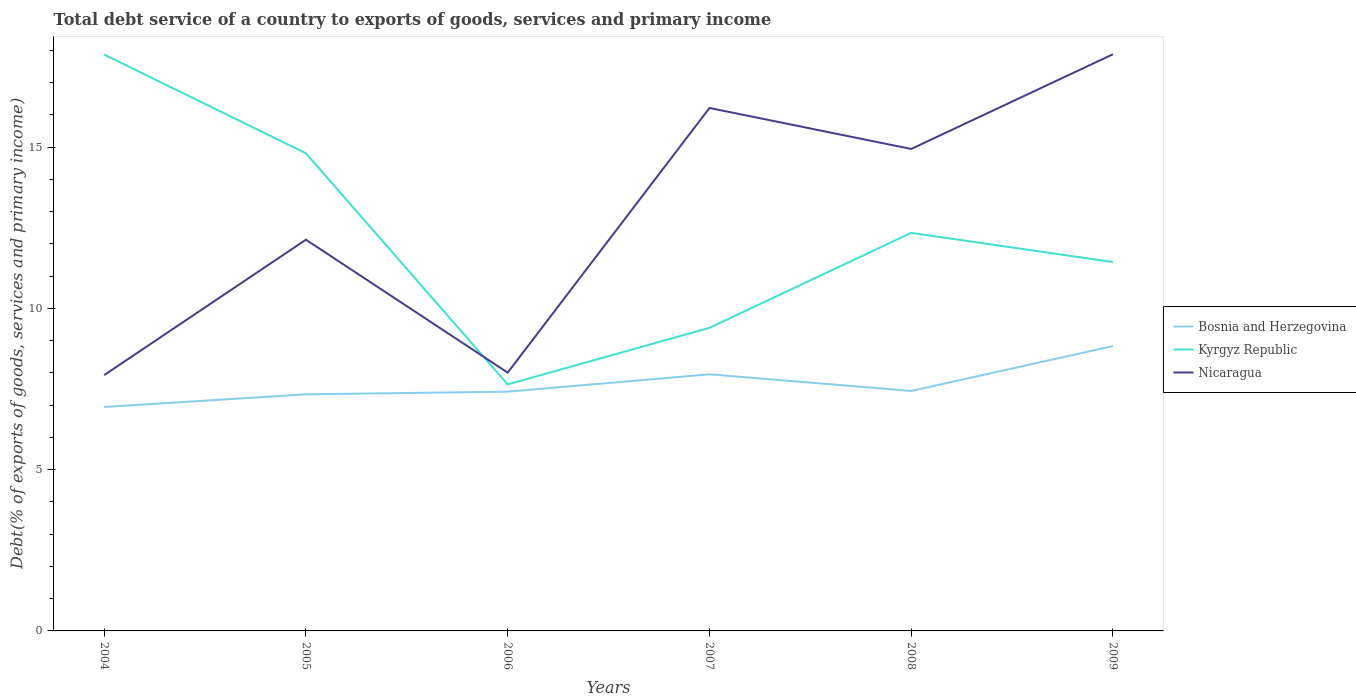Across all years, what is the maximum total debt service in Kyrgyz Republic?
Provide a succinct answer. 7.64. What is the total total debt service in Nicaragua in the graph?
Offer a terse response. -8.21. What is the difference between the highest and the second highest total debt service in Bosnia and Herzegovina?
Give a very brief answer. 1.89. What is the difference between the highest and the lowest total debt service in Kyrgyz Republic?
Ensure brevity in your answer.  3. Is the total debt service in Kyrgyz Republic strictly greater than the total debt service in Nicaragua over the years?
Provide a short and direct response. No. Does the graph contain grids?
Your response must be concise. No. Where does the legend appear in the graph?
Provide a short and direct response. Center right. How many legend labels are there?
Provide a succinct answer. 3. How are the legend labels stacked?
Offer a terse response. Vertical. What is the title of the graph?
Offer a terse response. Total debt service of a country to exports of goods, services and primary income. Does "Senegal" appear as one of the legend labels in the graph?
Give a very brief answer. No. What is the label or title of the X-axis?
Give a very brief answer. Years. What is the label or title of the Y-axis?
Your answer should be compact. Debt(% of exports of goods, services and primary income). What is the Debt(% of exports of goods, services and primary income) of Bosnia and Herzegovina in 2004?
Give a very brief answer. 6.94. What is the Debt(% of exports of goods, services and primary income) of Kyrgyz Republic in 2004?
Give a very brief answer. 17.87. What is the Debt(% of exports of goods, services and primary income) in Nicaragua in 2004?
Keep it short and to the point. 7.93. What is the Debt(% of exports of goods, services and primary income) in Bosnia and Herzegovina in 2005?
Keep it short and to the point. 7.34. What is the Debt(% of exports of goods, services and primary income) of Kyrgyz Republic in 2005?
Ensure brevity in your answer.  14.81. What is the Debt(% of exports of goods, services and primary income) of Nicaragua in 2005?
Your answer should be very brief. 12.13. What is the Debt(% of exports of goods, services and primary income) in Bosnia and Herzegovina in 2006?
Ensure brevity in your answer.  7.42. What is the Debt(% of exports of goods, services and primary income) in Kyrgyz Republic in 2006?
Provide a short and direct response. 7.64. What is the Debt(% of exports of goods, services and primary income) of Nicaragua in 2006?
Provide a succinct answer. 8.01. What is the Debt(% of exports of goods, services and primary income) of Bosnia and Herzegovina in 2007?
Your response must be concise. 7.96. What is the Debt(% of exports of goods, services and primary income) of Kyrgyz Republic in 2007?
Give a very brief answer. 9.4. What is the Debt(% of exports of goods, services and primary income) in Nicaragua in 2007?
Your answer should be very brief. 16.22. What is the Debt(% of exports of goods, services and primary income) in Bosnia and Herzegovina in 2008?
Make the answer very short. 7.44. What is the Debt(% of exports of goods, services and primary income) in Kyrgyz Republic in 2008?
Provide a succinct answer. 12.34. What is the Debt(% of exports of goods, services and primary income) of Nicaragua in 2008?
Provide a short and direct response. 14.94. What is the Debt(% of exports of goods, services and primary income) in Bosnia and Herzegovina in 2009?
Provide a succinct answer. 8.83. What is the Debt(% of exports of goods, services and primary income) in Kyrgyz Republic in 2009?
Your answer should be compact. 11.44. What is the Debt(% of exports of goods, services and primary income) in Nicaragua in 2009?
Provide a succinct answer. 17.88. Across all years, what is the maximum Debt(% of exports of goods, services and primary income) of Bosnia and Herzegovina?
Provide a short and direct response. 8.83. Across all years, what is the maximum Debt(% of exports of goods, services and primary income) in Kyrgyz Republic?
Make the answer very short. 17.87. Across all years, what is the maximum Debt(% of exports of goods, services and primary income) in Nicaragua?
Keep it short and to the point. 17.88. Across all years, what is the minimum Debt(% of exports of goods, services and primary income) in Bosnia and Herzegovina?
Your response must be concise. 6.94. Across all years, what is the minimum Debt(% of exports of goods, services and primary income) in Kyrgyz Republic?
Your response must be concise. 7.64. Across all years, what is the minimum Debt(% of exports of goods, services and primary income) of Nicaragua?
Offer a very short reply. 7.93. What is the total Debt(% of exports of goods, services and primary income) in Bosnia and Herzegovina in the graph?
Provide a succinct answer. 45.93. What is the total Debt(% of exports of goods, services and primary income) in Kyrgyz Republic in the graph?
Offer a very short reply. 73.5. What is the total Debt(% of exports of goods, services and primary income) of Nicaragua in the graph?
Your answer should be very brief. 77.11. What is the difference between the Debt(% of exports of goods, services and primary income) in Bosnia and Herzegovina in 2004 and that in 2005?
Offer a terse response. -0.39. What is the difference between the Debt(% of exports of goods, services and primary income) in Kyrgyz Republic in 2004 and that in 2005?
Provide a succinct answer. 3.06. What is the difference between the Debt(% of exports of goods, services and primary income) of Nicaragua in 2004 and that in 2005?
Offer a terse response. -4.2. What is the difference between the Debt(% of exports of goods, services and primary income) of Bosnia and Herzegovina in 2004 and that in 2006?
Provide a short and direct response. -0.47. What is the difference between the Debt(% of exports of goods, services and primary income) of Kyrgyz Republic in 2004 and that in 2006?
Give a very brief answer. 10.23. What is the difference between the Debt(% of exports of goods, services and primary income) of Nicaragua in 2004 and that in 2006?
Offer a very short reply. -0.08. What is the difference between the Debt(% of exports of goods, services and primary income) in Bosnia and Herzegovina in 2004 and that in 2007?
Your answer should be compact. -1.01. What is the difference between the Debt(% of exports of goods, services and primary income) in Kyrgyz Republic in 2004 and that in 2007?
Your response must be concise. 8.47. What is the difference between the Debt(% of exports of goods, services and primary income) of Nicaragua in 2004 and that in 2007?
Your answer should be compact. -8.28. What is the difference between the Debt(% of exports of goods, services and primary income) in Bosnia and Herzegovina in 2004 and that in 2008?
Your response must be concise. -0.5. What is the difference between the Debt(% of exports of goods, services and primary income) of Kyrgyz Republic in 2004 and that in 2008?
Your response must be concise. 5.53. What is the difference between the Debt(% of exports of goods, services and primary income) in Nicaragua in 2004 and that in 2008?
Ensure brevity in your answer.  -7.01. What is the difference between the Debt(% of exports of goods, services and primary income) of Bosnia and Herzegovina in 2004 and that in 2009?
Your response must be concise. -1.89. What is the difference between the Debt(% of exports of goods, services and primary income) in Kyrgyz Republic in 2004 and that in 2009?
Offer a very short reply. 6.43. What is the difference between the Debt(% of exports of goods, services and primary income) in Nicaragua in 2004 and that in 2009?
Provide a short and direct response. -9.95. What is the difference between the Debt(% of exports of goods, services and primary income) in Bosnia and Herzegovina in 2005 and that in 2006?
Keep it short and to the point. -0.08. What is the difference between the Debt(% of exports of goods, services and primary income) in Kyrgyz Republic in 2005 and that in 2006?
Ensure brevity in your answer.  7.17. What is the difference between the Debt(% of exports of goods, services and primary income) in Nicaragua in 2005 and that in 2006?
Keep it short and to the point. 4.12. What is the difference between the Debt(% of exports of goods, services and primary income) of Bosnia and Herzegovina in 2005 and that in 2007?
Your response must be concise. -0.62. What is the difference between the Debt(% of exports of goods, services and primary income) of Kyrgyz Republic in 2005 and that in 2007?
Your response must be concise. 5.41. What is the difference between the Debt(% of exports of goods, services and primary income) in Nicaragua in 2005 and that in 2007?
Make the answer very short. -4.08. What is the difference between the Debt(% of exports of goods, services and primary income) of Bosnia and Herzegovina in 2005 and that in 2008?
Your answer should be very brief. -0.11. What is the difference between the Debt(% of exports of goods, services and primary income) in Kyrgyz Republic in 2005 and that in 2008?
Ensure brevity in your answer.  2.47. What is the difference between the Debt(% of exports of goods, services and primary income) in Nicaragua in 2005 and that in 2008?
Your answer should be very brief. -2.81. What is the difference between the Debt(% of exports of goods, services and primary income) of Bosnia and Herzegovina in 2005 and that in 2009?
Give a very brief answer. -1.5. What is the difference between the Debt(% of exports of goods, services and primary income) of Kyrgyz Republic in 2005 and that in 2009?
Offer a very short reply. 3.37. What is the difference between the Debt(% of exports of goods, services and primary income) in Nicaragua in 2005 and that in 2009?
Offer a terse response. -5.75. What is the difference between the Debt(% of exports of goods, services and primary income) of Bosnia and Herzegovina in 2006 and that in 2007?
Your answer should be compact. -0.54. What is the difference between the Debt(% of exports of goods, services and primary income) of Kyrgyz Republic in 2006 and that in 2007?
Give a very brief answer. -1.75. What is the difference between the Debt(% of exports of goods, services and primary income) of Nicaragua in 2006 and that in 2007?
Offer a very short reply. -8.21. What is the difference between the Debt(% of exports of goods, services and primary income) of Bosnia and Herzegovina in 2006 and that in 2008?
Give a very brief answer. -0.02. What is the difference between the Debt(% of exports of goods, services and primary income) of Kyrgyz Republic in 2006 and that in 2008?
Offer a very short reply. -4.7. What is the difference between the Debt(% of exports of goods, services and primary income) in Nicaragua in 2006 and that in 2008?
Your response must be concise. -6.94. What is the difference between the Debt(% of exports of goods, services and primary income) in Bosnia and Herzegovina in 2006 and that in 2009?
Offer a very short reply. -1.41. What is the difference between the Debt(% of exports of goods, services and primary income) in Kyrgyz Republic in 2006 and that in 2009?
Ensure brevity in your answer.  -3.79. What is the difference between the Debt(% of exports of goods, services and primary income) of Nicaragua in 2006 and that in 2009?
Provide a succinct answer. -9.87. What is the difference between the Debt(% of exports of goods, services and primary income) in Bosnia and Herzegovina in 2007 and that in 2008?
Give a very brief answer. 0.52. What is the difference between the Debt(% of exports of goods, services and primary income) of Kyrgyz Republic in 2007 and that in 2008?
Make the answer very short. -2.94. What is the difference between the Debt(% of exports of goods, services and primary income) in Nicaragua in 2007 and that in 2008?
Offer a very short reply. 1.27. What is the difference between the Debt(% of exports of goods, services and primary income) of Bosnia and Herzegovina in 2007 and that in 2009?
Offer a very short reply. -0.88. What is the difference between the Debt(% of exports of goods, services and primary income) in Kyrgyz Republic in 2007 and that in 2009?
Your response must be concise. -2.04. What is the difference between the Debt(% of exports of goods, services and primary income) in Nicaragua in 2007 and that in 2009?
Provide a short and direct response. -1.67. What is the difference between the Debt(% of exports of goods, services and primary income) of Bosnia and Herzegovina in 2008 and that in 2009?
Give a very brief answer. -1.39. What is the difference between the Debt(% of exports of goods, services and primary income) in Kyrgyz Republic in 2008 and that in 2009?
Your response must be concise. 0.91. What is the difference between the Debt(% of exports of goods, services and primary income) of Nicaragua in 2008 and that in 2009?
Make the answer very short. -2.94. What is the difference between the Debt(% of exports of goods, services and primary income) of Bosnia and Herzegovina in 2004 and the Debt(% of exports of goods, services and primary income) of Kyrgyz Republic in 2005?
Provide a succinct answer. -7.87. What is the difference between the Debt(% of exports of goods, services and primary income) of Bosnia and Herzegovina in 2004 and the Debt(% of exports of goods, services and primary income) of Nicaragua in 2005?
Your answer should be compact. -5.19. What is the difference between the Debt(% of exports of goods, services and primary income) of Kyrgyz Republic in 2004 and the Debt(% of exports of goods, services and primary income) of Nicaragua in 2005?
Provide a succinct answer. 5.74. What is the difference between the Debt(% of exports of goods, services and primary income) of Bosnia and Herzegovina in 2004 and the Debt(% of exports of goods, services and primary income) of Kyrgyz Republic in 2006?
Your answer should be compact. -0.7. What is the difference between the Debt(% of exports of goods, services and primary income) of Bosnia and Herzegovina in 2004 and the Debt(% of exports of goods, services and primary income) of Nicaragua in 2006?
Ensure brevity in your answer.  -1.07. What is the difference between the Debt(% of exports of goods, services and primary income) in Kyrgyz Republic in 2004 and the Debt(% of exports of goods, services and primary income) in Nicaragua in 2006?
Your response must be concise. 9.86. What is the difference between the Debt(% of exports of goods, services and primary income) in Bosnia and Herzegovina in 2004 and the Debt(% of exports of goods, services and primary income) in Kyrgyz Republic in 2007?
Offer a terse response. -2.45. What is the difference between the Debt(% of exports of goods, services and primary income) of Bosnia and Herzegovina in 2004 and the Debt(% of exports of goods, services and primary income) of Nicaragua in 2007?
Provide a short and direct response. -9.27. What is the difference between the Debt(% of exports of goods, services and primary income) in Kyrgyz Republic in 2004 and the Debt(% of exports of goods, services and primary income) in Nicaragua in 2007?
Keep it short and to the point. 1.66. What is the difference between the Debt(% of exports of goods, services and primary income) of Bosnia and Herzegovina in 2004 and the Debt(% of exports of goods, services and primary income) of Kyrgyz Republic in 2008?
Your answer should be very brief. -5.4. What is the difference between the Debt(% of exports of goods, services and primary income) of Bosnia and Herzegovina in 2004 and the Debt(% of exports of goods, services and primary income) of Nicaragua in 2008?
Offer a terse response. -8. What is the difference between the Debt(% of exports of goods, services and primary income) of Kyrgyz Republic in 2004 and the Debt(% of exports of goods, services and primary income) of Nicaragua in 2008?
Make the answer very short. 2.93. What is the difference between the Debt(% of exports of goods, services and primary income) in Bosnia and Herzegovina in 2004 and the Debt(% of exports of goods, services and primary income) in Kyrgyz Republic in 2009?
Make the answer very short. -4.49. What is the difference between the Debt(% of exports of goods, services and primary income) in Bosnia and Herzegovina in 2004 and the Debt(% of exports of goods, services and primary income) in Nicaragua in 2009?
Provide a short and direct response. -10.94. What is the difference between the Debt(% of exports of goods, services and primary income) in Kyrgyz Republic in 2004 and the Debt(% of exports of goods, services and primary income) in Nicaragua in 2009?
Your response must be concise. -0.01. What is the difference between the Debt(% of exports of goods, services and primary income) in Bosnia and Herzegovina in 2005 and the Debt(% of exports of goods, services and primary income) in Kyrgyz Republic in 2006?
Keep it short and to the point. -0.31. What is the difference between the Debt(% of exports of goods, services and primary income) of Bosnia and Herzegovina in 2005 and the Debt(% of exports of goods, services and primary income) of Nicaragua in 2006?
Give a very brief answer. -0.67. What is the difference between the Debt(% of exports of goods, services and primary income) in Kyrgyz Republic in 2005 and the Debt(% of exports of goods, services and primary income) in Nicaragua in 2006?
Give a very brief answer. 6.8. What is the difference between the Debt(% of exports of goods, services and primary income) in Bosnia and Herzegovina in 2005 and the Debt(% of exports of goods, services and primary income) in Kyrgyz Republic in 2007?
Your answer should be very brief. -2.06. What is the difference between the Debt(% of exports of goods, services and primary income) in Bosnia and Herzegovina in 2005 and the Debt(% of exports of goods, services and primary income) in Nicaragua in 2007?
Your answer should be compact. -8.88. What is the difference between the Debt(% of exports of goods, services and primary income) of Kyrgyz Republic in 2005 and the Debt(% of exports of goods, services and primary income) of Nicaragua in 2007?
Offer a terse response. -1.4. What is the difference between the Debt(% of exports of goods, services and primary income) of Bosnia and Herzegovina in 2005 and the Debt(% of exports of goods, services and primary income) of Kyrgyz Republic in 2008?
Your answer should be compact. -5.01. What is the difference between the Debt(% of exports of goods, services and primary income) of Bosnia and Herzegovina in 2005 and the Debt(% of exports of goods, services and primary income) of Nicaragua in 2008?
Provide a succinct answer. -7.61. What is the difference between the Debt(% of exports of goods, services and primary income) of Kyrgyz Republic in 2005 and the Debt(% of exports of goods, services and primary income) of Nicaragua in 2008?
Offer a terse response. -0.13. What is the difference between the Debt(% of exports of goods, services and primary income) of Bosnia and Herzegovina in 2005 and the Debt(% of exports of goods, services and primary income) of Kyrgyz Republic in 2009?
Offer a very short reply. -4.1. What is the difference between the Debt(% of exports of goods, services and primary income) of Bosnia and Herzegovina in 2005 and the Debt(% of exports of goods, services and primary income) of Nicaragua in 2009?
Ensure brevity in your answer.  -10.55. What is the difference between the Debt(% of exports of goods, services and primary income) in Kyrgyz Republic in 2005 and the Debt(% of exports of goods, services and primary income) in Nicaragua in 2009?
Your response must be concise. -3.07. What is the difference between the Debt(% of exports of goods, services and primary income) of Bosnia and Herzegovina in 2006 and the Debt(% of exports of goods, services and primary income) of Kyrgyz Republic in 2007?
Offer a very short reply. -1.98. What is the difference between the Debt(% of exports of goods, services and primary income) of Bosnia and Herzegovina in 2006 and the Debt(% of exports of goods, services and primary income) of Nicaragua in 2007?
Offer a very short reply. -8.8. What is the difference between the Debt(% of exports of goods, services and primary income) in Kyrgyz Republic in 2006 and the Debt(% of exports of goods, services and primary income) in Nicaragua in 2007?
Give a very brief answer. -8.57. What is the difference between the Debt(% of exports of goods, services and primary income) of Bosnia and Herzegovina in 2006 and the Debt(% of exports of goods, services and primary income) of Kyrgyz Republic in 2008?
Make the answer very short. -4.92. What is the difference between the Debt(% of exports of goods, services and primary income) in Bosnia and Herzegovina in 2006 and the Debt(% of exports of goods, services and primary income) in Nicaragua in 2008?
Make the answer very short. -7.53. What is the difference between the Debt(% of exports of goods, services and primary income) in Kyrgyz Republic in 2006 and the Debt(% of exports of goods, services and primary income) in Nicaragua in 2008?
Offer a terse response. -7.3. What is the difference between the Debt(% of exports of goods, services and primary income) of Bosnia and Herzegovina in 2006 and the Debt(% of exports of goods, services and primary income) of Kyrgyz Republic in 2009?
Offer a terse response. -4.02. What is the difference between the Debt(% of exports of goods, services and primary income) of Bosnia and Herzegovina in 2006 and the Debt(% of exports of goods, services and primary income) of Nicaragua in 2009?
Offer a terse response. -10.46. What is the difference between the Debt(% of exports of goods, services and primary income) in Kyrgyz Republic in 2006 and the Debt(% of exports of goods, services and primary income) in Nicaragua in 2009?
Ensure brevity in your answer.  -10.24. What is the difference between the Debt(% of exports of goods, services and primary income) of Bosnia and Herzegovina in 2007 and the Debt(% of exports of goods, services and primary income) of Kyrgyz Republic in 2008?
Provide a short and direct response. -4.39. What is the difference between the Debt(% of exports of goods, services and primary income) in Bosnia and Herzegovina in 2007 and the Debt(% of exports of goods, services and primary income) in Nicaragua in 2008?
Provide a succinct answer. -6.99. What is the difference between the Debt(% of exports of goods, services and primary income) of Kyrgyz Republic in 2007 and the Debt(% of exports of goods, services and primary income) of Nicaragua in 2008?
Your response must be concise. -5.55. What is the difference between the Debt(% of exports of goods, services and primary income) in Bosnia and Herzegovina in 2007 and the Debt(% of exports of goods, services and primary income) in Kyrgyz Republic in 2009?
Your answer should be compact. -3.48. What is the difference between the Debt(% of exports of goods, services and primary income) in Bosnia and Herzegovina in 2007 and the Debt(% of exports of goods, services and primary income) in Nicaragua in 2009?
Make the answer very short. -9.93. What is the difference between the Debt(% of exports of goods, services and primary income) of Kyrgyz Republic in 2007 and the Debt(% of exports of goods, services and primary income) of Nicaragua in 2009?
Your answer should be very brief. -8.48. What is the difference between the Debt(% of exports of goods, services and primary income) of Bosnia and Herzegovina in 2008 and the Debt(% of exports of goods, services and primary income) of Kyrgyz Republic in 2009?
Provide a short and direct response. -4. What is the difference between the Debt(% of exports of goods, services and primary income) of Bosnia and Herzegovina in 2008 and the Debt(% of exports of goods, services and primary income) of Nicaragua in 2009?
Offer a very short reply. -10.44. What is the difference between the Debt(% of exports of goods, services and primary income) in Kyrgyz Republic in 2008 and the Debt(% of exports of goods, services and primary income) in Nicaragua in 2009?
Your response must be concise. -5.54. What is the average Debt(% of exports of goods, services and primary income) of Bosnia and Herzegovina per year?
Provide a short and direct response. 7.65. What is the average Debt(% of exports of goods, services and primary income) in Kyrgyz Republic per year?
Offer a terse response. 12.25. What is the average Debt(% of exports of goods, services and primary income) in Nicaragua per year?
Keep it short and to the point. 12.85. In the year 2004, what is the difference between the Debt(% of exports of goods, services and primary income) of Bosnia and Herzegovina and Debt(% of exports of goods, services and primary income) of Kyrgyz Republic?
Your response must be concise. -10.93. In the year 2004, what is the difference between the Debt(% of exports of goods, services and primary income) of Bosnia and Herzegovina and Debt(% of exports of goods, services and primary income) of Nicaragua?
Offer a very short reply. -0.99. In the year 2004, what is the difference between the Debt(% of exports of goods, services and primary income) in Kyrgyz Republic and Debt(% of exports of goods, services and primary income) in Nicaragua?
Provide a short and direct response. 9.94. In the year 2005, what is the difference between the Debt(% of exports of goods, services and primary income) in Bosnia and Herzegovina and Debt(% of exports of goods, services and primary income) in Kyrgyz Republic?
Offer a terse response. -7.48. In the year 2005, what is the difference between the Debt(% of exports of goods, services and primary income) of Bosnia and Herzegovina and Debt(% of exports of goods, services and primary income) of Nicaragua?
Your response must be concise. -4.8. In the year 2005, what is the difference between the Debt(% of exports of goods, services and primary income) of Kyrgyz Republic and Debt(% of exports of goods, services and primary income) of Nicaragua?
Your response must be concise. 2.68. In the year 2006, what is the difference between the Debt(% of exports of goods, services and primary income) of Bosnia and Herzegovina and Debt(% of exports of goods, services and primary income) of Kyrgyz Republic?
Ensure brevity in your answer.  -0.23. In the year 2006, what is the difference between the Debt(% of exports of goods, services and primary income) of Bosnia and Herzegovina and Debt(% of exports of goods, services and primary income) of Nicaragua?
Your answer should be compact. -0.59. In the year 2006, what is the difference between the Debt(% of exports of goods, services and primary income) of Kyrgyz Republic and Debt(% of exports of goods, services and primary income) of Nicaragua?
Give a very brief answer. -0.36. In the year 2007, what is the difference between the Debt(% of exports of goods, services and primary income) in Bosnia and Herzegovina and Debt(% of exports of goods, services and primary income) in Kyrgyz Republic?
Provide a short and direct response. -1.44. In the year 2007, what is the difference between the Debt(% of exports of goods, services and primary income) in Bosnia and Herzegovina and Debt(% of exports of goods, services and primary income) in Nicaragua?
Keep it short and to the point. -8.26. In the year 2007, what is the difference between the Debt(% of exports of goods, services and primary income) in Kyrgyz Republic and Debt(% of exports of goods, services and primary income) in Nicaragua?
Keep it short and to the point. -6.82. In the year 2008, what is the difference between the Debt(% of exports of goods, services and primary income) in Bosnia and Herzegovina and Debt(% of exports of goods, services and primary income) in Kyrgyz Republic?
Provide a succinct answer. -4.9. In the year 2008, what is the difference between the Debt(% of exports of goods, services and primary income) of Bosnia and Herzegovina and Debt(% of exports of goods, services and primary income) of Nicaragua?
Ensure brevity in your answer.  -7.5. In the year 2008, what is the difference between the Debt(% of exports of goods, services and primary income) in Kyrgyz Republic and Debt(% of exports of goods, services and primary income) in Nicaragua?
Provide a succinct answer. -2.6. In the year 2009, what is the difference between the Debt(% of exports of goods, services and primary income) in Bosnia and Herzegovina and Debt(% of exports of goods, services and primary income) in Kyrgyz Republic?
Your response must be concise. -2.6. In the year 2009, what is the difference between the Debt(% of exports of goods, services and primary income) in Bosnia and Herzegovina and Debt(% of exports of goods, services and primary income) in Nicaragua?
Provide a short and direct response. -9.05. In the year 2009, what is the difference between the Debt(% of exports of goods, services and primary income) in Kyrgyz Republic and Debt(% of exports of goods, services and primary income) in Nicaragua?
Your answer should be compact. -6.44. What is the ratio of the Debt(% of exports of goods, services and primary income) in Bosnia and Herzegovina in 2004 to that in 2005?
Provide a succinct answer. 0.95. What is the ratio of the Debt(% of exports of goods, services and primary income) in Kyrgyz Republic in 2004 to that in 2005?
Offer a very short reply. 1.21. What is the ratio of the Debt(% of exports of goods, services and primary income) in Nicaragua in 2004 to that in 2005?
Give a very brief answer. 0.65. What is the ratio of the Debt(% of exports of goods, services and primary income) in Bosnia and Herzegovina in 2004 to that in 2006?
Ensure brevity in your answer.  0.94. What is the ratio of the Debt(% of exports of goods, services and primary income) of Kyrgyz Republic in 2004 to that in 2006?
Make the answer very short. 2.34. What is the ratio of the Debt(% of exports of goods, services and primary income) in Nicaragua in 2004 to that in 2006?
Your answer should be compact. 0.99. What is the ratio of the Debt(% of exports of goods, services and primary income) of Bosnia and Herzegovina in 2004 to that in 2007?
Provide a short and direct response. 0.87. What is the ratio of the Debt(% of exports of goods, services and primary income) in Kyrgyz Republic in 2004 to that in 2007?
Offer a terse response. 1.9. What is the ratio of the Debt(% of exports of goods, services and primary income) in Nicaragua in 2004 to that in 2007?
Your response must be concise. 0.49. What is the ratio of the Debt(% of exports of goods, services and primary income) in Bosnia and Herzegovina in 2004 to that in 2008?
Keep it short and to the point. 0.93. What is the ratio of the Debt(% of exports of goods, services and primary income) of Kyrgyz Republic in 2004 to that in 2008?
Your response must be concise. 1.45. What is the ratio of the Debt(% of exports of goods, services and primary income) in Nicaragua in 2004 to that in 2008?
Give a very brief answer. 0.53. What is the ratio of the Debt(% of exports of goods, services and primary income) in Bosnia and Herzegovina in 2004 to that in 2009?
Ensure brevity in your answer.  0.79. What is the ratio of the Debt(% of exports of goods, services and primary income) of Kyrgyz Republic in 2004 to that in 2009?
Your response must be concise. 1.56. What is the ratio of the Debt(% of exports of goods, services and primary income) of Nicaragua in 2004 to that in 2009?
Offer a very short reply. 0.44. What is the ratio of the Debt(% of exports of goods, services and primary income) of Bosnia and Herzegovina in 2005 to that in 2006?
Keep it short and to the point. 0.99. What is the ratio of the Debt(% of exports of goods, services and primary income) of Kyrgyz Republic in 2005 to that in 2006?
Make the answer very short. 1.94. What is the ratio of the Debt(% of exports of goods, services and primary income) of Nicaragua in 2005 to that in 2006?
Your response must be concise. 1.51. What is the ratio of the Debt(% of exports of goods, services and primary income) in Bosnia and Herzegovina in 2005 to that in 2007?
Provide a short and direct response. 0.92. What is the ratio of the Debt(% of exports of goods, services and primary income) of Kyrgyz Republic in 2005 to that in 2007?
Offer a very short reply. 1.58. What is the ratio of the Debt(% of exports of goods, services and primary income) in Nicaragua in 2005 to that in 2007?
Offer a terse response. 0.75. What is the ratio of the Debt(% of exports of goods, services and primary income) in Bosnia and Herzegovina in 2005 to that in 2008?
Your response must be concise. 0.99. What is the ratio of the Debt(% of exports of goods, services and primary income) of Kyrgyz Republic in 2005 to that in 2008?
Give a very brief answer. 1.2. What is the ratio of the Debt(% of exports of goods, services and primary income) of Nicaragua in 2005 to that in 2008?
Provide a short and direct response. 0.81. What is the ratio of the Debt(% of exports of goods, services and primary income) in Bosnia and Herzegovina in 2005 to that in 2009?
Offer a terse response. 0.83. What is the ratio of the Debt(% of exports of goods, services and primary income) of Kyrgyz Republic in 2005 to that in 2009?
Provide a succinct answer. 1.29. What is the ratio of the Debt(% of exports of goods, services and primary income) in Nicaragua in 2005 to that in 2009?
Your response must be concise. 0.68. What is the ratio of the Debt(% of exports of goods, services and primary income) of Bosnia and Herzegovina in 2006 to that in 2007?
Ensure brevity in your answer.  0.93. What is the ratio of the Debt(% of exports of goods, services and primary income) in Kyrgyz Republic in 2006 to that in 2007?
Your answer should be compact. 0.81. What is the ratio of the Debt(% of exports of goods, services and primary income) of Nicaragua in 2006 to that in 2007?
Offer a very short reply. 0.49. What is the ratio of the Debt(% of exports of goods, services and primary income) of Kyrgyz Republic in 2006 to that in 2008?
Provide a succinct answer. 0.62. What is the ratio of the Debt(% of exports of goods, services and primary income) in Nicaragua in 2006 to that in 2008?
Your answer should be compact. 0.54. What is the ratio of the Debt(% of exports of goods, services and primary income) in Bosnia and Herzegovina in 2006 to that in 2009?
Keep it short and to the point. 0.84. What is the ratio of the Debt(% of exports of goods, services and primary income) of Kyrgyz Republic in 2006 to that in 2009?
Ensure brevity in your answer.  0.67. What is the ratio of the Debt(% of exports of goods, services and primary income) in Nicaragua in 2006 to that in 2009?
Provide a short and direct response. 0.45. What is the ratio of the Debt(% of exports of goods, services and primary income) in Bosnia and Herzegovina in 2007 to that in 2008?
Offer a very short reply. 1.07. What is the ratio of the Debt(% of exports of goods, services and primary income) in Kyrgyz Republic in 2007 to that in 2008?
Provide a short and direct response. 0.76. What is the ratio of the Debt(% of exports of goods, services and primary income) of Nicaragua in 2007 to that in 2008?
Provide a succinct answer. 1.08. What is the ratio of the Debt(% of exports of goods, services and primary income) in Bosnia and Herzegovina in 2007 to that in 2009?
Offer a very short reply. 0.9. What is the ratio of the Debt(% of exports of goods, services and primary income) in Kyrgyz Republic in 2007 to that in 2009?
Ensure brevity in your answer.  0.82. What is the ratio of the Debt(% of exports of goods, services and primary income) of Nicaragua in 2007 to that in 2009?
Keep it short and to the point. 0.91. What is the ratio of the Debt(% of exports of goods, services and primary income) of Bosnia and Herzegovina in 2008 to that in 2009?
Provide a succinct answer. 0.84. What is the ratio of the Debt(% of exports of goods, services and primary income) in Kyrgyz Republic in 2008 to that in 2009?
Keep it short and to the point. 1.08. What is the ratio of the Debt(% of exports of goods, services and primary income) of Nicaragua in 2008 to that in 2009?
Offer a terse response. 0.84. What is the difference between the highest and the second highest Debt(% of exports of goods, services and primary income) in Bosnia and Herzegovina?
Your response must be concise. 0.88. What is the difference between the highest and the second highest Debt(% of exports of goods, services and primary income) of Kyrgyz Republic?
Give a very brief answer. 3.06. What is the difference between the highest and the second highest Debt(% of exports of goods, services and primary income) of Nicaragua?
Offer a very short reply. 1.67. What is the difference between the highest and the lowest Debt(% of exports of goods, services and primary income) of Bosnia and Herzegovina?
Give a very brief answer. 1.89. What is the difference between the highest and the lowest Debt(% of exports of goods, services and primary income) in Kyrgyz Republic?
Ensure brevity in your answer.  10.23. What is the difference between the highest and the lowest Debt(% of exports of goods, services and primary income) of Nicaragua?
Ensure brevity in your answer.  9.95. 